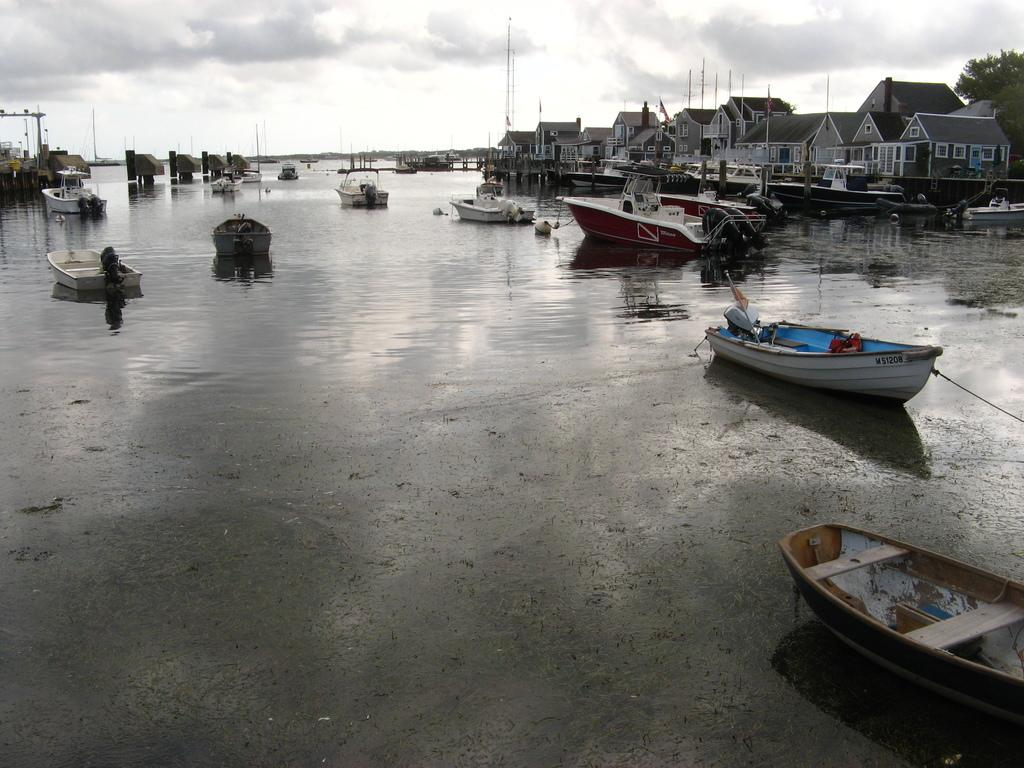What is on the water in the image? There are boats on the water in the image. What can be seen at the right side of the image? There are buildings, trees, and poles at the right side of the image. What type of comfort can be found in the image? The image does not depict any objects or elements related to comfort. How many fowls are visible in the image? There are no fowls present in the image. 